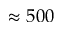Convert formula to latex. <formula><loc_0><loc_0><loc_500><loc_500>\approx 5 0 0</formula> 